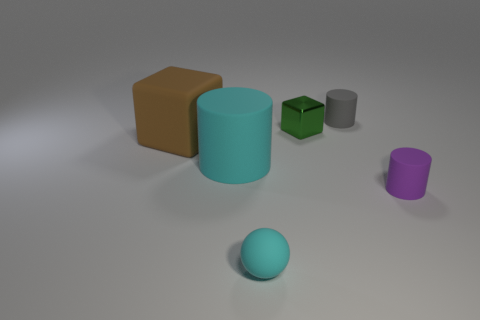Is the rubber sphere the same color as the big rubber cylinder?
Your answer should be very brief. Yes. What number of purple rubber cylinders have the same size as the green cube?
Make the answer very short. 1. What shape is the matte object that is the same color as the large cylinder?
Provide a succinct answer. Sphere. The tiny thing that is right of the tiny rubber cylinder that is on the left side of the tiny matte cylinder right of the gray cylinder is what shape?
Provide a short and direct response. Cylinder. There is a tiny matte cylinder behind the brown block; what is its color?
Make the answer very short. Gray. What number of things are either tiny objects that are behind the matte sphere or large matte things right of the rubber block?
Offer a very short reply. 4. How many tiny gray objects have the same shape as the tiny green shiny object?
Offer a terse response. 0. There is a cube that is the same size as the matte sphere; what is its color?
Your answer should be compact. Green. There is a cylinder that is on the left side of the cyan object in front of the tiny cylinder that is in front of the big rubber cube; what is its color?
Keep it short and to the point. Cyan. There is a gray rubber thing; is it the same size as the matte cylinder that is to the left of the green shiny object?
Keep it short and to the point. No. 